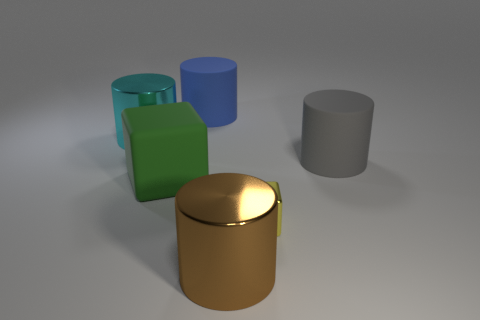What number of big yellow rubber objects are there?
Ensure brevity in your answer.  0. There is a metal cylinder in front of the green thing; is its size the same as the matte thing that is behind the big gray rubber cylinder?
Keep it short and to the point. Yes. There is another big rubber thing that is the same shape as the gray matte thing; what is its color?
Keep it short and to the point. Blue. Is the big green thing the same shape as the yellow shiny object?
Ensure brevity in your answer.  Yes. What size is the brown shiny object that is the same shape as the cyan metallic object?
Provide a short and direct response. Large. How many big brown things are made of the same material as the big brown cylinder?
Keep it short and to the point. 0. What number of things are either blue metallic cylinders or brown things?
Provide a succinct answer. 1. Are there any gray matte cylinders on the left side of the large shiny object to the left of the brown object?
Your answer should be very brief. No. Are there more big matte things that are in front of the big cyan thing than gray things that are in front of the big brown metallic cylinder?
Your response must be concise. Yes. How many cylinders have the same color as the big cube?
Provide a short and direct response. 0. 